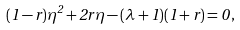Convert formula to latex. <formula><loc_0><loc_0><loc_500><loc_500>( 1 - r ) \eta ^ { 2 } + 2 r \eta - ( \lambda + 1 ) ( 1 + r ) = 0 \, ,</formula> 